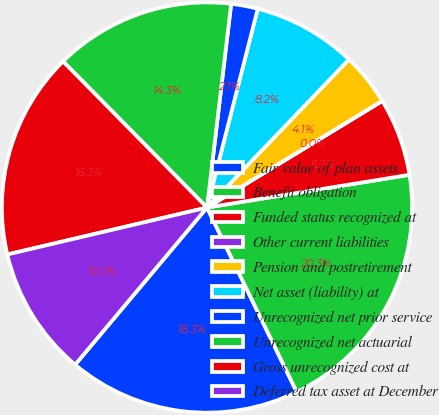Convert chart to OTSL. <chart><loc_0><loc_0><loc_500><loc_500><pie_chart><fcel>Fair value of plan assets<fcel>Benefit obligation<fcel>Funded status recognized at<fcel>Other current liabilities<fcel>Pension and postretirement<fcel>Net asset (liability) at<fcel>Unrecognized net prior service<fcel>Unrecognized net actuarial<fcel>Gross unrecognized cost at<fcel>Deferred tax asset at December<nl><fcel>18.32%<fcel>20.34%<fcel>6.15%<fcel>0.01%<fcel>4.13%<fcel>8.18%<fcel>2.1%<fcel>14.26%<fcel>16.29%<fcel>10.21%<nl></chart> 